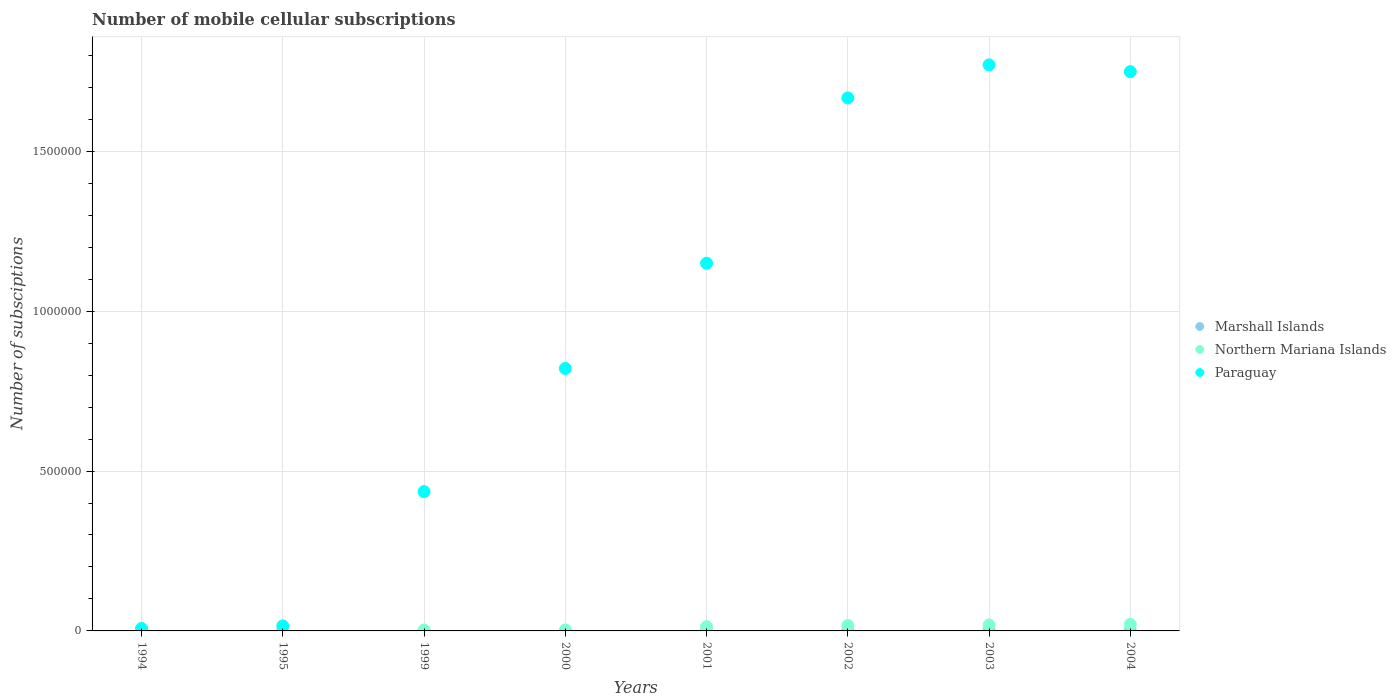What is the number of mobile cellular subscriptions in Marshall Islands in 1999?
Give a very brief answer. 443. Across all years, what is the maximum number of mobile cellular subscriptions in Marshall Islands?
Provide a short and direct response. 644. Across all years, what is the minimum number of mobile cellular subscriptions in Paraguay?
Offer a terse response. 7660. What is the total number of mobile cellular subscriptions in Marshall Islands in the graph?
Keep it short and to the point. 3717. What is the difference between the number of mobile cellular subscriptions in Paraguay in 2001 and that in 2002?
Keep it short and to the point. -5.17e+05. What is the difference between the number of mobile cellular subscriptions in Northern Mariana Islands in 2004 and the number of mobile cellular subscriptions in Paraguay in 1994?
Your answer should be compact. 1.28e+04. What is the average number of mobile cellular subscriptions in Northern Mariana Islands per year?
Offer a very short reply. 9662.5. In the year 2000, what is the difference between the number of mobile cellular subscriptions in Paraguay and number of mobile cellular subscriptions in Northern Mariana Islands?
Ensure brevity in your answer.  8.18e+05. What is the ratio of the number of mobile cellular subscriptions in Paraguay in 2002 to that in 2003?
Offer a terse response. 0.94. Is the difference between the number of mobile cellular subscriptions in Paraguay in 2000 and 2004 greater than the difference between the number of mobile cellular subscriptions in Northern Mariana Islands in 2000 and 2004?
Your response must be concise. No. What is the difference between the highest and the second highest number of mobile cellular subscriptions in Marshall Islands?
Offer a very short reply. 46. What is the difference between the highest and the lowest number of mobile cellular subscriptions in Marshall Islands?
Your answer should be very brief. 380. How many years are there in the graph?
Keep it short and to the point. 8. Does the graph contain any zero values?
Make the answer very short. No. Where does the legend appear in the graph?
Keep it short and to the point. Center right. How are the legend labels stacked?
Provide a short and direct response. Vertical. What is the title of the graph?
Give a very brief answer. Number of mobile cellular subscriptions. What is the label or title of the Y-axis?
Give a very brief answer. Number of subsciptions. What is the Number of subsciptions in Marshall Islands in 1994?
Make the answer very short. 280. What is the Number of subsciptions of Northern Mariana Islands in 1994?
Offer a terse response. 765. What is the Number of subsciptions of Paraguay in 1994?
Ensure brevity in your answer.  7660. What is the Number of subsciptions of Marshall Islands in 1995?
Your response must be concise. 264. What is the Number of subsciptions in Northern Mariana Islands in 1995?
Give a very brief answer. 1200. What is the Number of subsciptions of Paraguay in 1995?
Your response must be concise. 1.58e+04. What is the Number of subsciptions of Marshall Islands in 1999?
Keep it short and to the point. 443. What is the Number of subsciptions of Northern Mariana Islands in 1999?
Provide a succinct answer. 2905. What is the Number of subsciptions in Paraguay in 1999?
Your response must be concise. 4.36e+05. What is the Number of subsciptions in Marshall Islands in 2000?
Provide a succinct answer. 447. What is the Number of subsciptions of Northern Mariana Islands in 2000?
Make the answer very short. 3000. What is the Number of subsciptions in Paraguay in 2000?
Your response must be concise. 8.21e+05. What is the Number of subsciptions of Marshall Islands in 2001?
Your answer should be compact. 489. What is the Number of subsciptions in Northern Mariana Islands in 2001?
Provide a short and direct response. 1.32e+04. What is the Number of subsciptions of Paraguay in 2001?
Provide a succinct answer. 1.15e+06. What is the Number of subsciptions in Marshall Islands in 2002?
Make the answer very short. 552. What is the Number of subsciptions of Northern Mariana Islands in 2002?
Provide a short and direct response. 1.71e+04. What is the Number of subsciptions of Paraguay in 2002?
Provide a short and direct response. 1.67e+06. What is the Number of subsciptions in Marshall Islands in 2003?
Offer a terse response. 598. What is the Number of subsciptions in Northern Mariana Islands in 2003?
Provide a succinct answer. 1.86e+04. What is the Number of subsciptions in Paraguay in 2003?
Offer a terse response. 1.77e+06. What is the Number of subsciptions in Marshall Islands in 2004?
Ensure brevity in your answer.  644. What is the Number of subsciptions of Northern Mariana Islands in 2004?
Your answer should be compact. 2.05e+04. What is the Number of subsciptions in Paraguay in 2004?
Make the answer very short. 1.75e+06. Across all years, what is the maximum Number of subsciptions of Marshall Islands?
Ensure brevity in your answer.  644. Across all years, what is the maximum Number of subsciptions in Northern Mariana Islands?
Give a very brief answer. 2.05e+04. Across all years, what is the maximum Number of subsciptions of Paraguay?
Your response must be concise. 1.77e+06. Across all years, what is the minimum Number of subsciptions of Marshall Islands?
Provide a succinct answer. 264. Across all years, what is the minimum Number of subsciptions of Northern Mariana Islands?
Your answer should be very brief. 765. Across all years, what is the minimum Number of subsciptions of Paraguay?
Keep it short and to the point. 7660. What is the total Number of subsciptions in Marshall Islands in the graph?
Offer a very short reply. 3717. What is the total Number of subsciptions of Northern Mariana Islands in the graph?
Your response must be concise. 7.73e+04. What is the total Number of subsciptions of Paraguay in the graph?
Provide a succinct answer. 7.62e+06. What is the difference between the Number of subsciptions of Northern Mariana Islands in 1994 and that in 1995?
Offer a very short reply. -435. What is the difference between the Number of subsciptions of Paraguay in 1994 and that in 1995?
Make the answer very short. -8147. What is the difference between the Number of subsciptions in Marshall Islands in 1994 and that in 1999?
Ensure brevity in your answer.  -163. What is the difference between the Number of subsciptions of Northern Mariana Islands in 1994 and that in 1999?
Your response must be concise. -2140. What is the difference between the Number of subsciptions in Paraguay in 1994 and that in 1999?
Your answer should be compact. -4.28e+05. What is the difference between the Number of subsciptions in Marshall Islands in 1994 and that in 2000?
Give a very brief answer. -167. What is the difference between the Number of subsciptions in Northern Mariana Islands in 1994 and that in 2000?
Your answer should be compact. -2235. What is the difference between the Number of subsciptions in Paraguay in 1994 and that in 2000?
Make the answer very short. -8.13e+05. What is the difference between the Number of subsciptions in Marshall Islands in 1994 and that in 2001?
Ensure brevity in your answer.  -209. What is the difference between the Number of subsciptions of Northern Mariana Islands in 1994 and that in 2001?
Offer a very short reply. -1.24e+04. What is the difference between the Number of subsciptions in Paraguay in 1994 and that in 2001?
Offer a very short reply. -1.14e+06. What is the difference between the Number of subsciptions in Marshall Islands in 1994 and that in 2002?
Provide a succinct answer. -272. What is the difference between the Number of subsciptions in Northern Mariana Islands in 1994 and that in 2002?
Ensure brevity in your answer.  -1.64e+04. What is the difference between the Number of subsciptions in Paraguay in 1994 and that in 2002?
Keep it short and to the point. -1.66e+06. What is the difference between the Number of subsciptions in Marshall Islands in 1994 and that in 2003?
Give a very brief answer. -318. What is the difference between the Number of subsciptions of Northern Mariana Islands in 1994 and that in 2003?
Offer a very short reply. -1.79e+04. What is the difference between the Number of subsciptions in Paraguay in 1994 and that in 2003?
Provide a short and direct response. -1.76e+06. What is the difference between the Number of subsciptions in Marshall Islands in 1994 and that in 2004?
Offer a terse response. -364. What is the difference between the Number of subsciptions of Northern Mariana Islands in 1994 and that in 2004?
Keep it short and to the point. -1.97e+04. What is the difference between the Number of subsciptions of Paraguay in 1994 and that in 2004?
Provide a succinct answer. -1.74e+06. What is the difference between the Number of subsciptions of Marshall Islands in 1995 and that in 1999?
Provide a succinct answer. -179. What is the difference between the Number of subsciptions of Northern Mariana Islands in 1995 and that in 1999?
Make the answer very short. -1705. What is the difference between the Number of subsciptions of Paraguay in 1995 and that in 1999?
Give a very brief answer. -4.20e+05. What is the difference between the Number of subsciptions in Marshall Islands in 1995 and that in 2000?
Offer a terse response. -183. What is the difference between the Number of subsciptions in Northern Mariana Islands in 1995 and that in 2000?
Ensure brevity in your answer.  -1800. What is the difference between the Number of subsciptions in Paraguay in 1995 and that in 2000?
Offer a very short reply. -8.05e+05. What is the difference between the Number of subsciptions in Marshall Islands in 1995 and that in 2001?
Your response must be concise. -225. What is the difference between the Number of subsciptions in Northern Mariana Islands in 1995 and that in 2001?
Ensure brevity in your answer.  -1.20e+04. What is the difference between the Number of subsciptions in Paraguay in 1995 and that in 2001?
Offer a very short reply. -1.13e+06. What is the difference between the Number of subsciptions of Marshall Islands in 1995 and that in 2002?
Ensure brevity in your answer.  -288. What is the difference between the Number of subsciptions in Northern Mariana Islands in 1995 and that in 2002?
Offer a terse response. -1.59e+04. What is the difference between the Number of subsciptions of Paraguay in 1995 and that in 2002?
Provide a succinct answer. -1.65e+06. What is the difference between the Number of subsciptions of Marshall Islands in 1995 and that in 2003?
Offer a terse response. -334. What is the difference between the Number of subsciptions of Northern Mariana Islands in 1995 and that in 2003?
Provide a succinct answer. -1.74e+04. What is the difference between the Number of subsciptions in Paraguay in 1995 and that in 2003?
Your answer should be compact. -1.75e+06. What is the difference between the Number of subsciptions in Marshall Islands in 1995 and that in 2004?
Offer a terse response. -380. What is the difference between the Number of subsciptions in Northern Mariana Islands in 1995 and that in 2004?
Keep it short and to the point. -1.93e+04. What is the difference between the Number of subsciptions in Paraguay in 1995 and that in 2004?
Offer a very short reply. -1.73e+06. What is the difference between the Number of subsciptions in Marshall Islands in 1999 and that in 2000?
Keep it short and to the point. -4. What is the difference between the Number of subsciptions of Northern Mariana Islands in 1999 and that in 2000?
Your answer should be very brief. -95. What is the difference between the Number of subsciptions of Paraguay in 1999 and that in 2000?
Offer a terse response. -3.85e+05. What is the difference between the Number of subsciptions of Marshall Islands in 1999 and that in 2001?
Provide a succinct answer. -46. What is the difference between the Number of subsciptions in Northern Mariana Islands in 1999 and that in 2001?
Ensure brevity in your answer.  -1.03e+04. What is the difference between the Number of subsciptions in Paraguay in 1999 and that in 2001?
Your response must be concise. -7.14e+05. What is the difference between the Number of subsciptions in Marshall Islands in 1999 and that in 2002?
Your response must be concise. -109. What is the difference between the Number of subsciptions of Northern Mariana Islands in 1999 and that in 2002?
Offer a very short reply. -1.42e+04. What is the difference between the Number of subsciptions of Paraguay in 1999 and that in 2002?
Your response must be concise. -1.23e+06. What is the difference between the Number of subsciptions in Marshall Islands in 1999 and that in 2003?
Your response must be concise. -155. What is the difference between the Number of subsciptions in Northern Mariana Islands in 1999 and that in 2003?
Keep it short and to the point. -1.57e+04. What is the difference between the Number of subsciptions in Paraguay in 1999 and that in 2003?
Your response must be concise. -1.33e+06. What is the difference between the Number of subsciptions of Marshall Islands in 1999 and that in 2004?
Your answer should be very brief. -201. What is the difference between the Number of subsciptions in Northern Mariana Islands in 1999 and that in 2004?
Provide a short and direct response. -1.76e+04. What is the difference between the Number of subsciptions in Paraguay in 1999 and that in 2004?
Give a very brief answer. -1.31e+06. What is the difference between the Number of subsciptions of Marshall Islands in 2000 and that in 2001?
Give a very brief answer. -42. What is the difference between the Number of subsciptions of Northern Mariana Islands in 2000 and that in 2001?
Offer a terse response. -1.02e+04. What is the difference between the Number of subsciptions in Paraguay in 2000 and that in 2001?
Ensure brevity in your answer.  -3.29e+05. What is the difference between the Number of subsciptions of Marshall Islands in 2000 and that in 2002?
Provide a succinct answer. -105. What is the difference between the Number of subsciptions in Northern Mariana Islands in 2000 and that in 2002?
Your response must be concise. -1.41e+04. What is the difference between the Number of subsciptions of Paraguay in 2000 and that in 2002?
Offer a very short reply. -8.46e+05. What is the difference between the Number of subsciptions in Marshall Islands in 2000 and that in 2003?
Your answer should be compact. -151. What is the difference between the Number of subsciptions in Northern Mariana Islands in 2000 and that in 2003?
Make the answer very short. -1.56e+04. What is the difference between the Number of subsciptions of Paraguay in 2000 and that in 2003?
Make the answer very short. -9.50e+05. What is the difference between the Number of subsciptions of Marshall Islands in 2000 and that in 2004?
Offer a terse response. -197. What is the difference between the Number of subsciptions of Northern Mariana Islands in 2000 and that in 2004?
Give a very brief answer. -1.75e+04. What is the difference between the Number of subsciptions in Paraguay in 2000 and that in 2004?
Offer a very short reply. -9.28e+05. What is the difference between the Number of subsciptions in Marshall Islands in 2001 and that in 2002?
Provide a short and direct response. -63. What is the difference between the Number of subsciptions in Northern Mariana Islands in 2001 and that in 2002?
Make the answer very short. -3937. What is the difference between the Number of subsciptions of Paraguay in 2001 and that in 2002?
Your answer should be compact. -5.17e+05. What is the difference between the Number of subsciptions of Marshall Islands in 2001 and that in 2003?
Your response must be concise. -109. What is the difference between the Number of subsciptions in Northern Mariana Islands in 2001 and that in 2003?
Make the answer very short. -5419. What is the difference between the Number of subsciptions in Paraguay in 2001 and that in 2003?
Your answer should be compact. -6.20e+05. What is the difference between the Number of subsciptions in Marshall Islands in 2001 and that in 2004?
Offer a very short reply. -155. What is the difference between the Number of subsciptions of Northern Mariana Islands in 2001 and that in 2004?
Your answer should be compact. -7274. What is the difference between the Number of subsciptions in Paraguay in 2001 and that in 2004?
Make the answer very short. -5.99e+05. What is the difference between the Number of subsciptions of Marshall Islands in 2002 and that in 2003?
Offer a very short reply. -46. What is the difference between the Number of subsciptions in Northern Mariana Islands in 2002 and that in 2003?
Make the answer very short. -1482. What is the difference between the Number of subsciptions of Paraguay in 2002 and that in 2003?
Offer a terse response. -1.03e+05. What is the difference between the Number of subsciptions of Marshall Islands in 2002 and that in 2004?
Your response must be concise. -92. What is the difference between the Number of subsciptions in Northern Mariana Islands in 2002 and that in 2004?
Make the answer very short. -3337. What is the difference between the Number of subsciptions in Paraguay in 2002 and that in 2004?
Make the answer very short. -8.20e+04. What is the difference between the Number of subsciptions of Marshall Islands in 2003 and that in 2004?
Give a very brief answer. -46. What is the difference between the Number of subsciptions of Northern Mariana Islands in 2003 and that in 2004?
Provide a succinct answer. -1855. What is the difference between the Number of subsciptions in Paraguay in 2003 and that in 2004?
Your answer should be very brief. 2.13e+04. What is the difference between the Number of subsciptions in Marshall Islands in 1994 and the Number of subsciptions in Northern Mariana Islands in 1995?
Your answer should be very brief. -920. What is the difference between the Number of subsciptions of Marshall Islands in 1994 and the Number of subsciptions of Paraguay in 1995?
Offer a terse response. -1.55e+04. What is the difference between the Number of subsciptions in Northern Mariana Islands in 1994 and the Number of subsciptions in Paraguay in 1995?
Ensure brevity in your answer.  -1.50e+04. What is the difference between the Number of subsciptions in Marshall Islands in 1994 and the Number of subsciptions in Northern Mariana Islands in 1999?
Keep it short and to the point. -2625. What is the difference between the Number of subsciptions in Marshall Islands in 1994 and the Number of subsciptions in Paraguay in 1999?
Provide a succinct answer. -4.35e+05. What is the difference between the Number of subsciptions in Northern Mariana Islands in 1994 and the Number of subsciptions in Paraguay in 1999?
Provide a succinct answer. -4.35e+05. What is the difference between the Number of subsciptions of Marshall Islands in 1994 and the Number of subsciptions of Northern Mariana Islands in 2000?
Make the answer very short. -2720. What is the difference between the Number of subsciptions in Marshall Islands in 1994 and the Number of subsciptions in Paraguay in 2000?
Provide a succinct answer. -8.21e+05. What is the difference between the Number of subsciptions in Northern Mariana Islands in 1994 and the Number of subsciptions in Paraguay in 2000?
Offer a terse response. -8.20e+05. What is the difference between the Number of subsciptions in Marshall Islands in 1994 and the Number of subsciptions in Northern Mariana Islands in 2001?
Make the answer very short. -1.29e+04. What is the difference between the Number of subsciptions in Marshall Islands in 1994 and the Number of subsciptions in Paraguay in 2001?
Offer a terse response. -1.15e+06. What is the difference between the Number of subsciptions in Northern Mariana Islands in 1994 and the Number of subsciptions in Paraguay in 2001?
Give a very brief answer. -1.15e+06. What is the difference between the Number of subsciptions of Marshall Islands in 1994 and the Number of subsciptions of Northern Mariana Islands in 2002?
Your response must be concise. -1.69e+04. What is the difference between the Number of subsciptions in Marshall Islands in 1994 and the Number of subsciptions in Paraguay in 2002?
Give a very brief answer. -1.67e+06. What is the difference between the Number of subsciptions of Northern Mariana Islands in 1994 and the Number of subsciptions of Paraguay in 2002?
Ensure brevity in your answer.  -1.67e+06. What is the difference between the Number of subsciptions of Marshall Islands in 1994 and the Number of subsciptions of Northern Mariana Islands in 2003?
Ensure brevity in your answer.  -1.83e+04. What is the difference between the Number of subsciptions in Marshall Islands in 1994 and the Number of subsciptions in Paraguay in 2003?
Give a very brief answer. -1.77e+06. What is the difference between the Number of subsciptions of Northern Mariana Islands in 1994 and the Number of subsciptions of Paraguay in 2003?
Ensure brevity in your answer.  -1.77e+06. What is the difference between the Number of subsciptions of Marshall Islands in 1994 and the Number of subsciptions of Northern Mariana Islands in 2004?
Make the answer very short. -2.02e+04. What is the difference between the Number of subsciptions in Marshall Islands in 1994 and the Number of subsciptions in Paraguay in 2004?
Provide a succinct answer. -1.75e+06. What is the difference between the Number of subsciptions of Northern Mariana Islands in 1994 and the Number of subsciptions of Paraguay in 2004?
Provide a succinct answer. -1.75e+06. What is the difference between the Number of subsciptions in Marshall Islands in 1995 and the Number of subsciptions in Northern Mariana Islands in 1999?
Your answer should be very brief. -2641. What is the difference between the Number of subsciptions of Marshall Islands in 1995 and the Number of subsciptions of Paraguay in 1999?
Keep it short and to the point. -4.35e+05. What is the difference between the Number of subsciptions in Northern Mariana Islands in 1995 and the Number of subsciptions in Paraguay in 1999?
Your answer should be compact. -4.34e+05. What is the difference between the Number of subsciptions in Marshall Islands in 1995 and the Number of subsciptions in Northern Mariana Islands in 2000?
Your answer should be very brief. -2736. What is the difference between the Number of subsciptions in Marshall Islands in 1995 and the Number of subsciptions in Paraguay in 2000?
Offer a terse response. -8.21e+05. What is the difference between the Number of subsciptions in Northern Mariana Islands in 1995 and the Number of subsciptions in Paraguay in 2000?
Your answer should be very brief. -8.20e+05. What is the difference between the Number of subsciptions of Marshall Islands in 1995 and the Number of subsciptions of Northern Mariana Islands in 2001?
Keep it short and to the point. -1.29e+04. What is the difference between the Number of subsciptions in Marshall Islands in 1995 and the Number of subsciptions in Paraguay in 2001?
Offer a terse response. -1.15e+06. What is the difference between the Number of subsciptions in Northern Mariana Islands in 1995 and the Number of subsciptions in Paraguay in 2001?
Give a very brief answer. -1.15e+06. What is the difference between the Number of subsciptions of Marshall Islands in 1995 and the Number of subsciptions of Northern Mariana Islands in 2002?
Offer a very short reply. -1.69e+04. What is the difference between the Number of subsciptions of Marshall Islands in 1995 and the Number of subsciptions of Paraguay in 2002?
Offer a terse response. -1.67e+06. What is the difference between the Number of subsciptions of Northern Mariana Islands in 1995 and the Number of subsciptions of Paraguay in 2002?
Ensure brevity in your answer.  -1.67e+06. What is the difference between the Number of subsciptions in Marshall Islands in 1995 and the Number of subsciptions in Northern Mariana Islands in 2003?
Your answer should be very brief. -1.84e+04. What is the difference between the Number of subsciptions of Marshall Islands in 1995 and the Number of subsciptions of Paraguay in 2003?
Your response must be concise. -1.77e+06. What is the difference between the Number of subsciptions in Northern Mariana Islands in 1995 and the Number of subsciptions in Paraguay in 2003?
Ensure brevity in your answer.  -1.77e+06. What is the difference between the Number of subsciptions in Marshall Islands in 1995 and the Number of subsciptions in Northern Mariana Islands in 2004?
Offer a very short reply. -2.02e+04. What is the difference between the Number of subsciptions of Marshall Islands in 1995 and the Number of subsciptions of Paraguay in 2004?
Offer a terse response. -1.75e+06. What is the difference between the Number of subsciptions in Northern Mariana Islands in 1995 and the Number of subsciptions in Paraguay in 2004?
Keep it short and to the point. -1.75e+06. What is the difference between the Number of subsciptions in Marshall Islands in 1999 and the Number of subsciptions in Northern Mariana Islands in 2000?
Make the answer very short. -2557. What is the difference between the Number of subsciptions in Marshall Islands in 1999 and the Number of subsciptions in Paraguay in 2000?
Your answer should be very brief. -8.20e+05. What is the difference between the Number of subsciptions of Northern Mariana Islands in 1999 and the Number of subsciptions of Paraguay in 2000?
Your response must be concise. -8.18e+05. What is the difference between the Number of subsciptions in Marshall Islands in 1999 and the Number of subsciptions in Northern Mariana Islands in 2001?
Your answer should be compact. -1.28e+04. What is the difference between the Number of subsciptions of Marshall Islands in 1999 and the Number of subsciptions of Paraguay in 2001?
Your response must be concise. -1.15e+06. What is the difference between the Number of subsciptions in Northern Mariana Islands in 1999 and the Number of subsciptions in Paraguay in 2001?
Make the answer very short. -1.15e+06. What is the difference between the Number of subsciptions in Marshall Islands in 1999 and the Number of subsciptions in Northern Mariana Islands in 2002?
Give a very brief answer. -1.67e+04. What is the difference between the Number of subsciptions of Marshall Islands in 1999 and the Number of subsciptions of Paraguay in 2002?
Give a very brief answer. -1.67e+06. What is the difference between the Number of subsciptions of Northern Mariana Islands in 1999 and the Number of subsciptions of Paraguay in 2002?
Provide a short and direct response. -1.66e+06. What is the difference between the Number of subsciptions in Marshall Islands in 1999 and the Number of subsciptions in Northern Mariana Islands in 2003?
Keep it short and to the point. -1.82e+04. What is the difference between the Number of subsciptions in Marshall Islands in 1999 and the Number of subsciptions in Paraguay in 2003?
Your answer should be very brief. -1.77e+06. What is the difference between the Number of subsciptions of Northern Mariana Islands in 1999 and the Number of subsciptions of Paraguay in 2003?
Provide a succinct answer. -1.77e+06. What is the difference between the Number of subsciptions of Marshall Islands in 1999 and the Number of subsciptions of Northern Mariana Islands in 2004?
Provide a short and direct response. -2.00e+04. What is the difference between the Number of subsciptions of Marshall Islands in 1999 and the Number of subsciptions of Paraguay in 2004?
Ensure brevity in your answer.  -1.75e+06. What is the difference between the Number of subsciptions in Northern Mariana Islands in 1999 and the Number of subsciptions in Paraguay in 2004?
Offer a terse response. -1.75e+06. What is the difference between the Number of subsciptions in Marshall Islands in 2000 and the Number of subsciptions in Northern Mariana Islands in 2001?
Offer a very short reply. -1.28e+04. What is the difference between the Number of subsciptions of Marshall Islands in 2000 and the Number of subsciptions of Paraguay in 2001?
Your answer should be very brief. -1.15e+06. What is the difference between the Number of subsciptions of Northern Mariana Islands in 2000 and the Number of subsciptions of Paraguay in 2001?
Offer a very short reply. -1.15e+06. What is the difference between the Number of subsciptions in Marshall Islands in 2000 and the Number of subsciptions in Northern Mariana Islands in 2002?
Make the answer very short. -1.67e+04. What is the difference between the Number of subsciptions of Marshall Islands in 2000 and the Number of subsciptions of Paraguay in 2002?
Ensure brevity in your answer.  -1.67e+06. What is the difference between the Number of subsciptions in Northern Mariana Islands in 2000 and the Number of subsciptions in Paraguay in 2002?
Provide a succinct answer. -1.66e+06. What is the difference between the Number of subsciptions in Marshall Islands in 2000 and the Number of subsciptions in Northern Mariana Islands in 2003?
Your response must be concise. -1.82e+04. What is the difference between the Number of subsciptions in Marshall Islands in 2000 and the Number of subsciptions in Paraguay in 2003?
Make the answer very short. -1.77e+06. What is the difference between the Number of subsciptions of Northern Mariana Islands in 2000 and the Number of subsciptions of Paraguay in 2003?
Make the answer very short. -1.77e+06. What is the difference between the Number of subsciptions of Marshall Islands in 2000 and the Number of subsciptions of Northern Mariana Islands in 2004?
Provide a succinct answer. -2.00e+04. What is the difference between the Number of subsciptions in Marshall Islands in 2000 and the Number of subsciptions in Paraguay in 2004?
Offer a terse response. -1.75e+06. What is the difference between the Number of subsciptions of Northern Mariana Islands in 2000 and the Number of subsciptions of Paraguay in 2004?
Your response must be concise. -1.75e+06. What is the difference between the Number of subsciptions of Marshall Islands in 2001 and the Number of subsciptions of Northern Mariana Islands in 2002?
Make the answer very short. -1.66e+04. What is the difference between the Number of subsciptions of Marshall Islands in 2001 and the Number of subsciptions of Paraguay in 2002?
Give a very brief answer. -1.67e+06. What is the difference between the Number of subsciptions of Northern Mariana Islands in 2001 and the Number of subsciptions of Paraguay in 2002?
Your response must be concise. -1.65e+06. What is the difference between the Number of subsciptions in Marshall Islands in 2001 and the Number of subsciptions in Northern Mariana Islands in 2003?
Make the answer very short. -1.81e+04. What is the difference between the Number of subsciptions in Marshall Islands in 2001 and the Number of subsciptions in Paraguay in 2003?
Provide a succinct answer. -1.77e+06. What is the difference between the Number of subsciptions in Northern Mariana Islands in 2001 and the Number of subsciptions in Paraguay in 2003?
Offer a very short reply. -1.76e+06. What is the difference between the Number of subsciptions in Marshall Islands in 2001 and the Number of subsciptions in Northern Mariana Islands in 2004?
Provide a succinct answer. -2.00e+04. What is the difference between the Number of subsciptions of Marshall Islands in 2001 and the Number of subsciptions of Paraguay in 2004?
Keep it short and to the point. -1.75e+06. What is the difference between the Number of subsciptions in Northern Mariana Islands in 2001 and the Number of subsciptions in Paraguay in 2004?
Make the answer very short. -1.74e+06. What is the difference between the Number of subsciptions of Marshall Islands in 2002 and the Number of subsciptions of Northern Mariana Islands in 2003?
Give a very brief answer. -1.81e+04. What is the difference between the Number of subsciptions of Marshall Islands in 2002 and the Number of subsciptions of Paraguay in 2003?
Offer a terse response. -1.77e+06. What is the difference between the Number of subsciptions in Northern Mariana Islands in 2002 and the Number of subsciptions in Paraguay in 2003?
Offer a very short reply. -1.75e+06. What is the difference between the Number of subsciptions in Marshall Islands in 2002 and the Number of subsciptions in Northern Mariana Islands in 2004?
Provide a succinct answer. -1.99e+04. What is the difference between the Number of subsciptions of Marshall Islands in 2002 and the Number of subsciptions of Paraguay in 2004?
Your answer should be compact. -1.75e+06. What is the difference between the Number of subsciptions of Northern Mariana Islands in 2002 and the Number of subsciptions of Paraguay in 2004?
Provide a short and direct response. -1.73e+06. What is the difference between the Number of subsciptions of Marshall Islands in 2003 and the Number of subsciptions of Northern Mariana Islands in 2004?
Your answer should be very brief. -1.99e+04. What is the difference between the Number of subsciptions of Marshall Islands in 2003 and the Number of subsciptions of Paraguay in 2004?
Give a very brief answer. -1.75e+06. What is the difference between the Number of subsciptions in Northern Mariana Islands in 2003 and the Number of subsciptions in Paraguay in 2004?
Offer a terse response. -1.73e+06. What is the average Number of subsciptions in Marshall Islands per year?
Give a very brief answer. 464.62. What is the average Number of subsciptions in Northern Mariana Islands per year?
Your answer should be very brief. 9662.5. What is the average Number of subsciptions of Paraguay per year?
Offer a very short reply. 9.52e+05. In the year 1994, what is the difference between the Number of subsciptions in Marshall Islands and Number of subsciptions in Northern Mariana Islands?
Offer a very short reply. -485. In the year 1994, what is the difference between the Number of subsciptions in Marshall Islands and Number of subsciptions in Paraguay?
Provide a succinct answer. -7380. In the year 1994, what is the difference between the Number of subsciptions of Northern Mariana Islands and Number of subsciptions of Paraguay?
Ensure brevity in your answer.  -6895. In the year 1995, what is the difference between the Number of subsciptions of Marshall Islands and Number of subsciptions of Northern Mariana Islands?
Your response must be concise. -936. In the year 1995, what is the difference between the Number of subsciptions in Marshall Islands and Number of subsciptions in Paraguay?
Keep it short and to the point. -1.55e+04. In the year 1995, what is the difference between the Number of subsciptions of Northern Mariana Islands and Number of subsciptions of Paraguay?
Your answer should be compact. -1.46e+04. In the year 1999, what is the difference between the Number of subsciptions in Marshall Islands and Number of subsciptions in Northern Mariana Islands?
Provide a succinct answer. -2462. In the year 1999, what is the difference between the Number of subsciptions of Marshall Islands and Number of subsciptions of Paraguay?
Provide a succinct answer. -4.35e+05. In the year 1999, what is the difference between the Number of subsciptions in Northern Mariana Islands and Number of subsciptions in Paraguay?
Make the answer very short. -4.33e+05. In the year 2000, what is the difference between the Number of subsciptions of Marshall Islands and Number of subsciptions of Northern Mariana Islands?
Keep it short and to the point. -2553. In the year 2000, what is the difference between the Number of subsciptions of Marshall Islands and Number of subsciptions of Paraguay?
Offer a terse response. -8.20e+05. In the year 2000, what is the difference between the Number of subsciptions in Northern Mariana Islands and Number of subsciptions in Paraguay?
Provide a short and direct response. -8.18e+05. In the year 2001, what is the difference between the Number of subsciptions in Marshall Islands and Number of subsciptions in Northern Mariana Islands?
Keep it short and to the point. -1.27e+04. In the year 2001, what is the difference between the Number of subsciptions in Marshall Islands and Number of subsciptions in Paraguay?
Give a very brief answer. -1.15e+06. In the year 2001, what is the difference between the Number of subsciptions of Northern Mariana Islands and Number of subsciptions of Paraguay?
Provide a short and direct response. -1.14e+06. In the year 2002, what is the difference between the Number of subsciptions in Marshall Islands and Number of subsciptions in Northern Mariana Islands?
Provide a succinct answer. -1.66e+04. In the year 2002, what is the difference between the Number of subsciptions in Marshall Islands and Number of subsciptions in Paraguay?
Give a very brief answer. -1.67e+06. In the year 2002, what is the difference between the Number of subsciptions in Northern Mariana Islands and Number of subsciptions in Paraguay?
Your response must be concise. -1.65e+06. In the year 2003, what is the difference between the Number of subsciptions of Marshall Islands and Number of subsciptions of Northern Mariana Islands?
Your answer should be very brief. -1.80e+04. In the year 2003, what is the difference between the Number of subsciptions of Marshall Islands and Number of subsciptions of Paraguay?
Keep it short and to the point. -1.77e+06. In the year 2003, what is the difference between the Number of subsciptions in Northern Mariana Islands and Number of subsciptions in Paraguay?
Ensure brevity in your answer.  -1.75e+06. In the year 2004, what is the difference between the Number of subsciptions in Marshall Islands and Number of subsciptions in Northern Mariana Islands?
Ensure brevity in your answer.  -1.98e+04. In the year 2004, what is the difference between the Number of subsciptions of Marshall Islands and Number of subsciptions of Paraguay?
Your answer should be very brief. -1.75e+06. In the year 2004, what is the difference between the Number of subsciptions of Northern Mariana Islands and Number of subsciptions of Paraguay?
Make the answer very short. -1.73e+06. What is the ratio of the Number of subsciptions of Marshall Islands in 1994 to that in 1995?
Ensure brevity in your answer.  1.06. What is the ratio of the Number of subsciptions of Northern Mariana Islands in 1994 to that in 1995?
Give a very brief answer. 0.64. What is the ratio of the Number of subsciptions of Paraguay in 1994 to that in 1995?
Your response must be concise. 0.48. What is the ratio of the Number of subsciptions in Marshall Islands in 1994 to that in 1999?
Provide a short and direct response. 0.63. What is the ratio of the Number of subsciptions in Northern Mariana Islands in 1994 to that in 1999?
Ensure brevity in your answer.  0.26. What is the ratio of the Number of subsciptions of Paraguay in 1994 to that in 1999?
Provide a succinct answer. 0.02. What is the ratio of the Number of subsciptions of Marshall Islands in 1994 to that in 2000?
Offer a very short reply. 0.63. What is the ratio of the Number of subsciptions in Northern Mariana Islands in 1994 to that in 2000?
Your response must be concise. 0.26. What is the ratio of the Number of subsciptions of Paraguay in 1994 to that in 2000?
Your answer should be compact. 0.01. What is the ratio of the Number of subsciptions of Marshall Islands in 1994 to that in 2001?
Provide a short and direct response. 0.57. What is the ratio of the Number of subsciptions in Northern Mariana Islands in 1994 to that in 2001?
Your answer should be very brief. 0.06. What is the ratio of the Number of subsciptions of Paraguay in 1994 to that in 2001?
Offer a terse response. 0.01. What is the ratio of the Number of subsciptions in Marshall Islands in 1994 to that in 2002?
Make the answer very short. 0.51. What is the ratio of the Number of subsciptions in Northern Mariana Islands in 1994 to that in 2002?
Your response must be concise. 0.04. What is the ratio of the Number of subsciptions of Paraguay in 1994 to that in 2002?
Your answer should be very brief. 0. What is the ratio of the Number of subsciptions of Marshall Islands in 1994 to that in 2003?
Keep it short and to the point. 0.47. What is the ratio of the Number of subsciptions in Northern Mariana Islands in 1994 to that in 2003?
Provide a succinct answer. 0.04. What is the ratio of the Number of subsciptions in Paraguay in 1994 to that in 2003?
Give a very brief answer. 0. What is the ratio of the Number of subsciptions in Marshall Islands in 1994 to that in 2004?
Make the answer very short. 0.43. What is the ratio of the Number of subsciptions in Northern Mariana Islands in 1994 to that in 2004?
Provide a succinct answer. 0.04. What is the ratio of the Number of subsciptions of Paraguay in 1994 to that in 2004?
Your response must be concise. 0. What is the ratio of the Number of subsciptions in Marshall Islands in 1995 to that in 1999?
Provide a short and direct response. 0.6. What is the ratio of the Number of subsciptions of Northern Mariana Islands in 1995 to that in 1999?
Your response must be concise. 0.41. What is the ratio of the Number of subsciptions in Paraguay in 1995 to that in 1999?
Ensure brevity in your answer.  0.04. What is the ratio of the Number of subsciptions of Marshall Islands in 1995 to that in 2000?
Provide a short and direct response. 0.59. What is the ratio of the Number of subsciptions of Northern Mariana Islands in 1995 to that in 2000?
Provide a succinct answer. 0.4. What is the ratio of the Number of subsciptions of Paraguay in 1995 to that in 2000?
Offer a terse response. 0.02. What is the ratio of the Number of subsciptions in Marshall Islands in 1995 to that in 2001?
Your answer should be very brief. 0.54. What is the ratio of the Number of subsciptions of Northern Mariana Islands in 1995 to that in 2001?
Your response must be concise. 0.09. What is the ratio of the Number of subsciptions in Paraguay in 1995 to that in 2001?
Offer a very short reply. 0.01. What is the ratio of the Number of subsciptions in Marshall Islands in 1995 to that in 2002?
Keep it short and to the point. 0.48. What is the ratio of the Number of subsciptions of Northern Mariana Islands in 1995 to that in 2002?
Make the answer very short. 0.07. What is the ratio of the Number of subsciptions of Paraguay in 1995 to that in 2002?
Offer a terse response. 0.01. What is the ratio of the Number of subsciptions in Marshall Islands in 1995 to that in 2003?
Give a very brief answer. 0.44. What is the ratio of the Number of subsciptions in Northern Mariana Islands in 1995 to that in 2003?
Your response must be concise. 0.06. What is the ratio of the Number of subsciptions in Paraguay in 1995 to that in 2003?
Offer a very short reply. 0.01. What is the ratio of the Number of subsciptions in Marshall Islands in 1995 to that in 2004?
Make the answer very short. 0.41. What is the ratio of the Number of subsciptions of Northern Mariana Islands in 1995 to that in 2004?
Your answer should be very brief. 0.06. What is the ratio of the Number of subsciptions of Paraguay in 1995 to that in 2004?
Keep it short and to the point. 0.01. What is the ratio of the Number of subsciptions in Northern Mariana Islands in 1999 to that in 2000?
Keep it short and to the point. 0.97. What is the ratio of the Number of subsciptions of Paraguay in 1999 to that in 2000?
Make the answer very short. 0.53. What is the ratio of the Number of subsciptions in Marshall Islands in 1999 to that in 2001?
Your answer should be compact. 0.91. What is the ratio of the Number of subsciptions of Northern Mariana Islands in 1999 to that in 2001?
Provide a short and direct response. 0.22. What is the ratio of the Number of subsciptions of Paraguay in 1999 to that in 2001?
Keep it short and to the point. 0.38. What is the ratio of the Number of subsciptions in Marshall Islands in 1999 to that in 2002?
Provide a succinct answer. 0.8. What is the ratio of the Number of subsciptions in Northern Mariana Islands in 1999 to that in 2002?
Offer a very short reply. 0.17. What is the ratio of the Number of subsciptions of Paraguay in 1999 to that in 2002?
Give a very brief answer. 0.26. What is the ratio of the Number of subsciptions in Marshall Islands in 1999 to that in 2003?
Provide a short and direct response. 0.74. What is the ratio of the Number of subsciptions in Northern Mariana Islands in 1999 to that in 2003?
Give a very brief answer. 0.16. What is the ratio of the Number of subsciptions in Paraguay in 1999 to that in 2003?
Provide a short and direct response. 0.25. What is the ratio of the Number of subsciptions of Marshall Islands in 1999 to that in 2004?
Your response must be concise. 0.69. What is the ratio of the Number of subsciptions of Northern Mariana Islands in 1999 to that in 2004?
Provide a succinct answer. 0.14. What is the ratio of the Number of subsciptions of Paraguay in 1999 to that in 2004?
Give a very brief answer. 0.25. What is the ratio of the Number of subsciptions of Marshall Islands in 2000 to that in 2001?
Provide a short and direct response. 0.91. What is the ratio of the Number of subsciptions in Northern Mariana Islands in 2000 to that in 2001?
Your answer should be compact. 0.23. What is the ratio of the Number of subsciptions of Paraguay in 2000 to that in 2001?
Ensure brevity in your answer.  0.71. What is the ratio of the Number of subsciptions in Marshall Islands in 2000 to that in 2002?
Offer a terse response. 0.81. What is the ratio of the Number of subsciptions in Northern Mariana Islands in 2000 to that in 2002?
Provide a short and direct response. 0.18. What is the ratio of the Number of subsciptions in Paraguay in 2000 to that in 2002?
Offer a terse response. 0.49. What is the ratio of the Number of subsciptions of Marshall Islands in 2000 to that in 2003?
Provide a short and direct response. 0.75. What is the ratio of the Number of subsciptions of Northern Mariana Islands in 2000 to that in 2003?
Keep it short and to the point. 0.16. What is the ratio of the Number of subsciptions in Paraguay in 2000 to that in 2003?
Make the answer very short. 0.46. What is the ratio of the Number of subsciptions in Marshall Islands in 2000 to that in 2004?
Make the answer very short. 0.69. What is the ratio of the Number of subsciptions of Northern Mariana Islands in 2000 to that in 2004?
Offer a very short reply. 0.15. What is the ratio of the Number of subsciptions in Paraguay in 2000 to that in 2004?
Offer a terse response. 0.47. What is the ratio of the Number of subsciptions of Marshall Islands in 2001 to that in 2002?
Make the answer very short. 0.89. What is the ratio of the Number of subsciptions of Northern Mariana Islands in 2001 to that in 2002?
Your answer should be very brief. 0.77. What is the ratio of the Number of subsciptions of Paraguay in 2001 to that in 2002?
Provide a short and direct response. 0.69. What is the ratio of the Number of subsciptions in Marshall Islands in 2001 to that in 2003?
Your response must be concise. 0.82. What is the ratio of the Number of subsciptions in Northern Mariana Islands in 2001 to that in 2003?
Your answer should be compact. 0.71. What is the ratio of the Number of subsciptions of Paraguay in 2001 to that in 2003?
Ensure brevity in your answer.  0.65. What is the ratio of the Number of subsciptions in Marshall Islands in 2001 to that in 2004?
Offer a terse response. 0.76. What is the ratio of the Number of subsciptions in Northern Mariana Islands in 2001 to that in 2004?
Offer a terse response. 0.64. What is the ratio of the Number of subsciptions of Paraguay in 2001 to that in 2004?
Your response must be concise. 0.66. What is the ratio of the Number of subsciptions in Northern Mariana Islands in 2002 to that in 2003?
Offer a terse response. 0.92. What is the ratio of the Number of subsciptions of Paraguay in 2002 to that in 2003?
Your answer should be compact. 0.94. What is the ratio of the Number of subsciptions of Marshall Islands in 2002 to that in 2004?
Offer a terse response. 0.86. What is the ratio of the Number of subsciptions in Northern Mariana Islands in 2002 to that in 2004?
Provide a succinct answer. 0.84. What is the ratio of the Number of subsciptions in Paraguay in 2002 to that in 2004?
Provide a succinct answer. 0.95. What is the ratio of the Number of subsciptions of Marshall Islands in 2003 to that in 2004?
Your answer should be very brief. 0.93. What is the ratio of the Number of subsciptions of Northern Mariana Islands in 2003 to that in 2004?
Offer a terse response. 0.91. What is the ratio of the Number of subsciptions of Paraguay in 2003 to that in 2004?
Give a very brief answer. 1.01. What is the difference between the highest and the second highest Number of subsciptions in Northern Mariana Islands?
Offer a very short reply. 1855. What is the difference between the highest and the second highest Number of subsciptions of Paraguay?
Ensure brevity in your answer.  2.13e+04. What is the difference between the highest and the lowest Number of subsciptions in Marshall Islands?
Provide a short and direct response. 380. What is the difference between the highest and the lowest Number of subsciptions of Northern Mariana Islands?
Offer a terse response. 1.97e+04. What is the difference between the highest and the lowest Number of subsciptions of Paraguay?
Your response must be concise. 1.76e+06. 